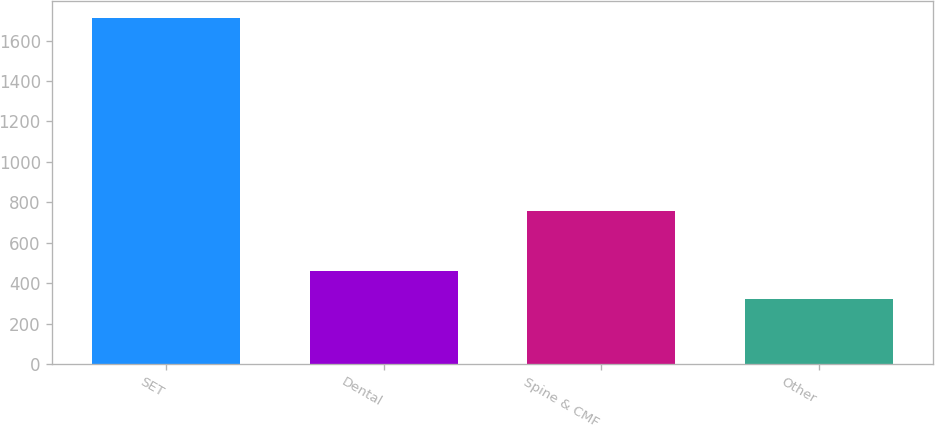Convert chart to OTSL. <chart><loc_0><loc_0><loc_500><loc_500><bar_chart><fcel>SET<fcel>Dental<fcel>Spine & CMF<fcel>Other<nl><fcel>1709.1<fcel>459.54<fcel>759.5<fcel>320.7<nl></chart> 